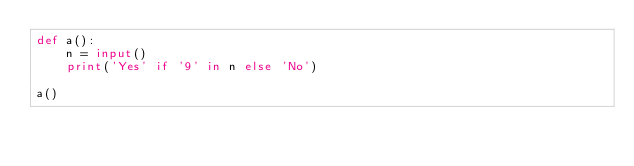<code> <loc_0><loc_0><loc_500><loc_500><_Python_>def a():
    n = input()
    print('Yes' if '9' in n else 'No')

a()</code> 